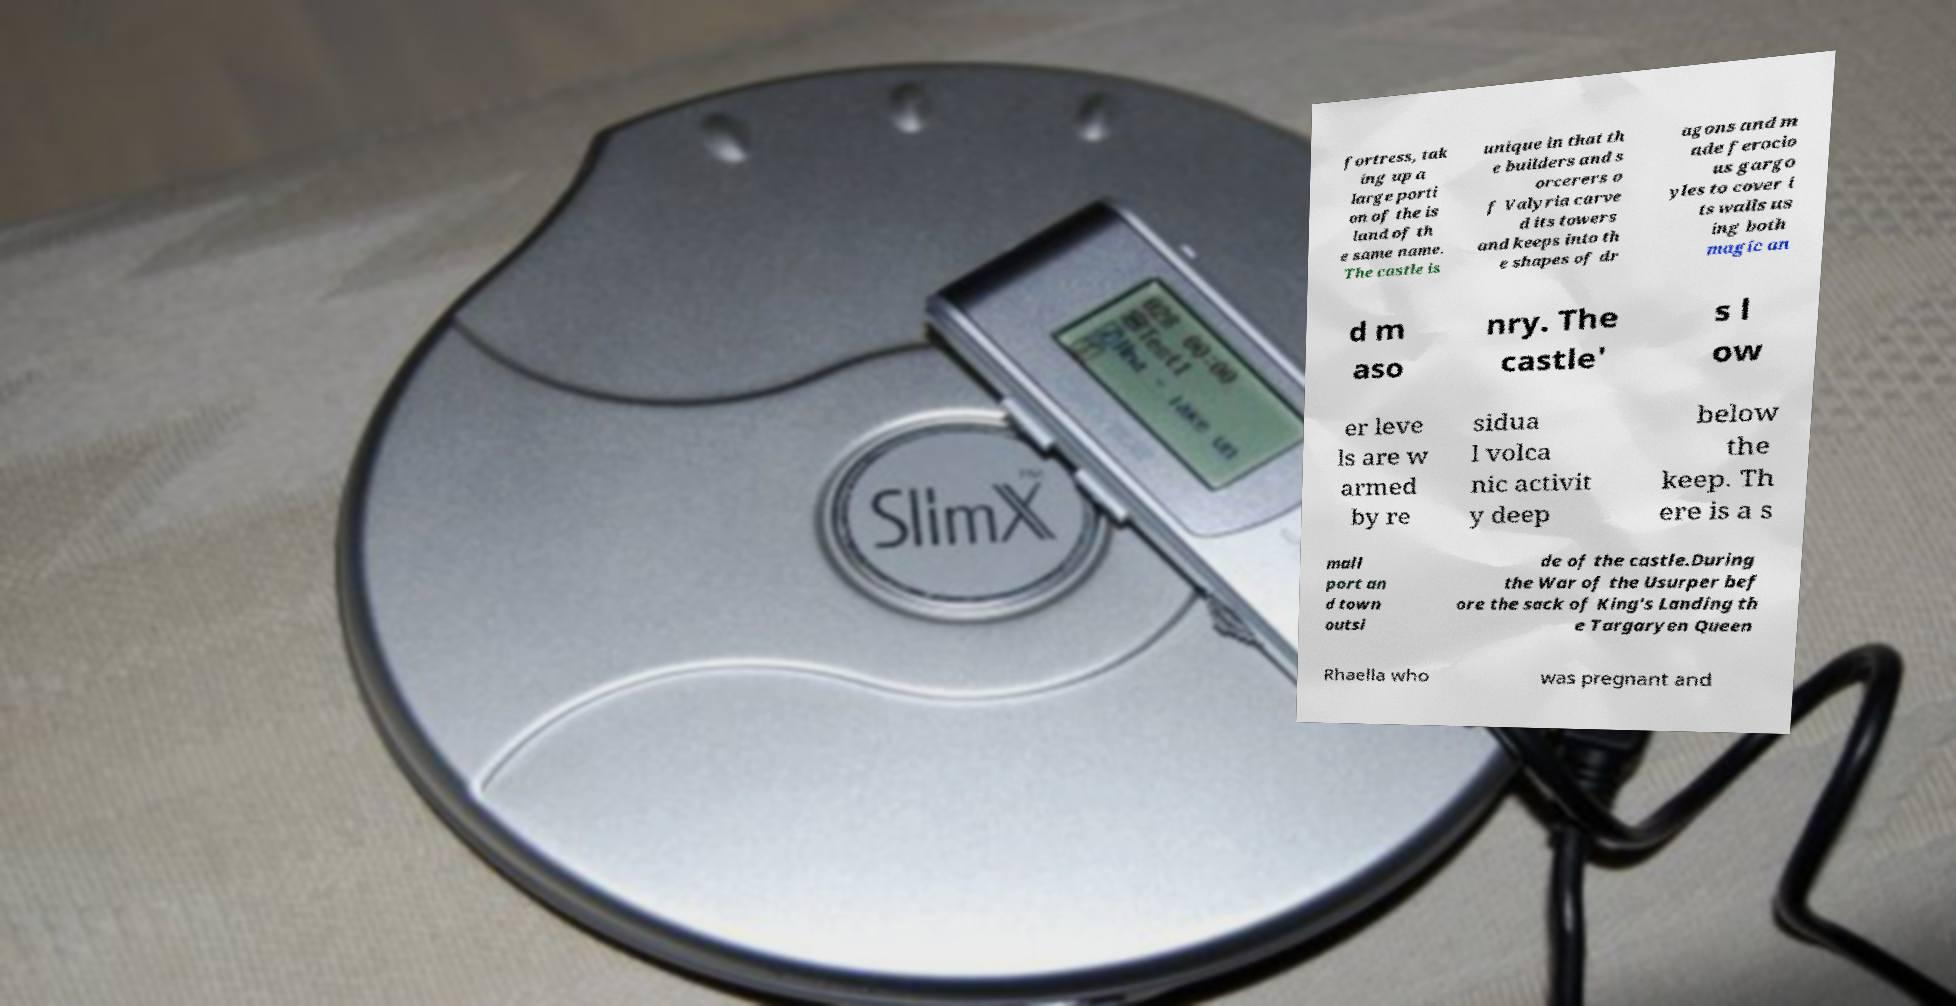There's text embedded in this image that I need extracted. Can you transcribe it verbatim? fortress, tak ing up a large porti on of the is land of th e same name. The castle is unique in that th e builders and s orcerers o f Valyria carve d its towers and keeps into th e shapes of dr agons and m ade ferocio us gargo yles to cover i ts walls us ing both magic an d m aso nry. The castle' s l ow er leve ls are w armed by re sidua l volca nic activit y deep below the keep. Th ere is a s mall port an d town outsi de of the castle.During the War of the Usurper bef ore the sack of King's Landing th e Targaryen Queen Rhaella who was pregnant and 